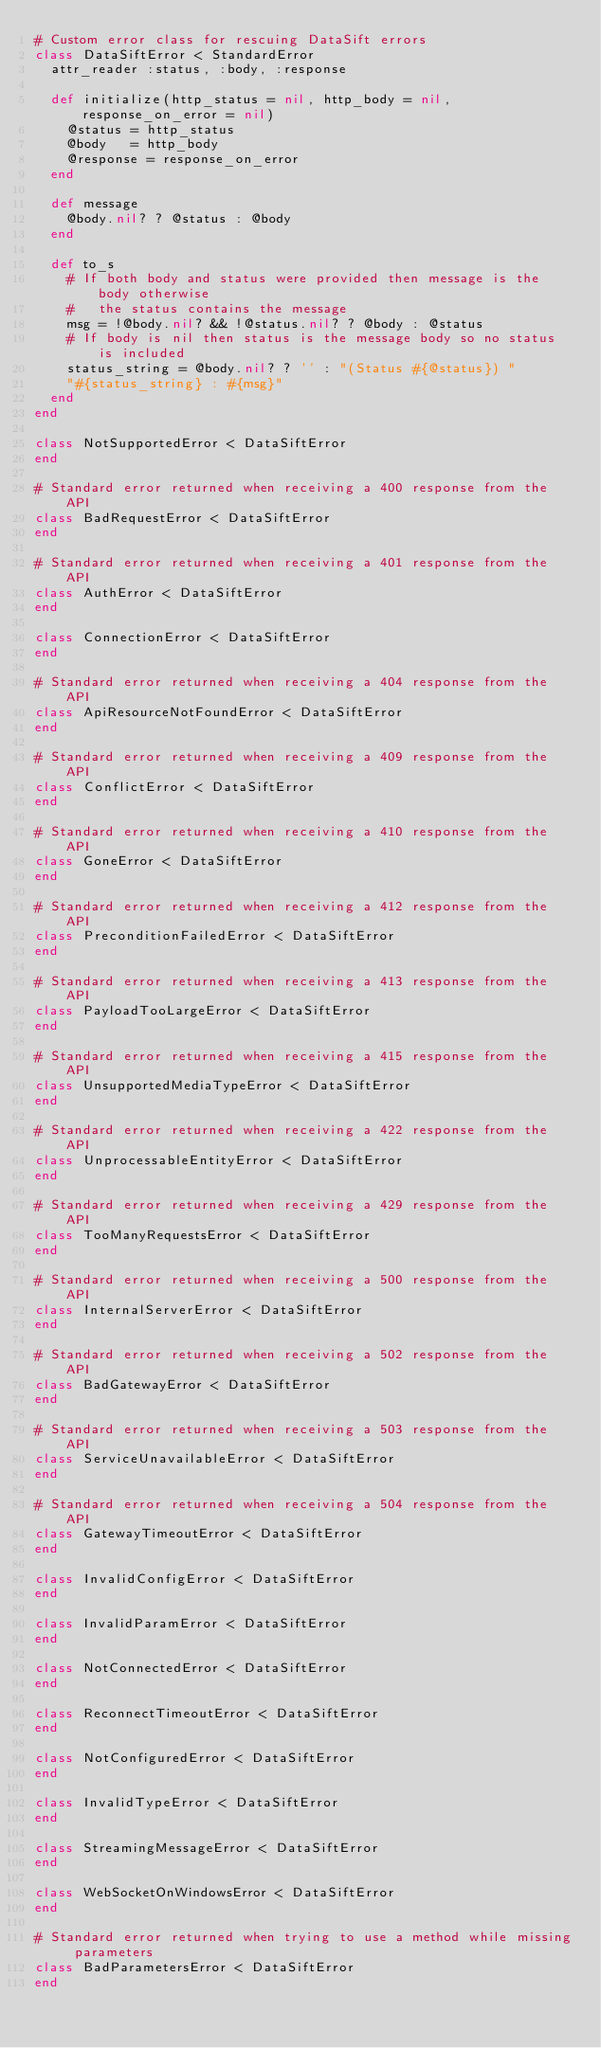<code> <loc_0><loc_0><loc_500><loc_500><_Ruby_># Custom error class for rescuing DataSift errors
class DataSiftError < StandardError
  attr_reader :status, :body, :response

  def initialize(http_status = nil, http_body = nil, response_on_error = nil)
    @status = http_status
    @body   = http_body
    @response = response_on_error
  end

  def message
    @body.nil? ? @status : @body
  end

  def to_s
    # If both body and status were provided then message is the body otherwise
    #   the status contains the message
    msg = !@body.nil? && !@status.nil? ? @body : @status
    # If body is nil then status is the message body so no status is included
    status_string = @body.nil? ? '' : "(Status #{@status}) "
    "#{status_string} : #{msg}"
  end
end

class NotSupportedError < DataSiftError
end

# Standard error returned when receiving a 400 response from the API
class BadRequestError < DataSiftError
end

# Standard error returned when receiving a 401 response from the API
class AuthError < DataSiftError
end

class ConnectionError < DataSiftError
end

# Standard error returned when receiving a 404 response from the API
class ApiResourceNotFoundError < DataSiftError
end

# Standard error returned when receiving a 409 response from the API
class ConflictError < DataSiftError
end

# Standard error returned when receiving a 410 response from the API
class GoneError < DataSiftError
end

# Standard error returned when receiving a 412 response from the API
class PreconditionFailedError < DataSiftError
end

# Standard error returned when receiving a 413 response from the API
class PayloadTooLargeError < DataSiftError
end

# Standard error returned when receiving a 415 response from the API
class UnsupportedMediaTypeError < DataSiftError
end

# Standard error returned when receiving a 422 response from the API
class UnprocessableEntityError < DataSiftError
end

# Standard error returned when receiving a 429 response from the API
class TooManyRequestsError < DataSiftError
end

# Standard error returned when receiving a 500 response from the API
class InternalServerError < DataSiftError
end

# Standard error returned when receiving a 502 response from the API
class BadGatewayError < DataSiftError
end

# Standard error returned when receiving a 503 response from the API
class ServiceUnavailableError < DataSiftError
end

# Standard error returned when receiving a 504 response from the API
class GatewayTimeoutError < DataSiftError
end

class InvalidConfigError < DataSiftError
end

class InvalidParamError < DataSiftError
end

class NotConnectedError < DataSiftError
end

class ReconnectTimeoutError < DataSiftError
end

class NotConfiguredError < DataSiftError
end

class InvalidTypeError < DataSiftError
end

class StreamingMessageError < DataSiftError
end

class WebSocketOnWindowsError < DataSiftError
end

# Standard error returned when trying to use a method while missing parameters
class BadParametersError < DataSiftError
end
</code> 